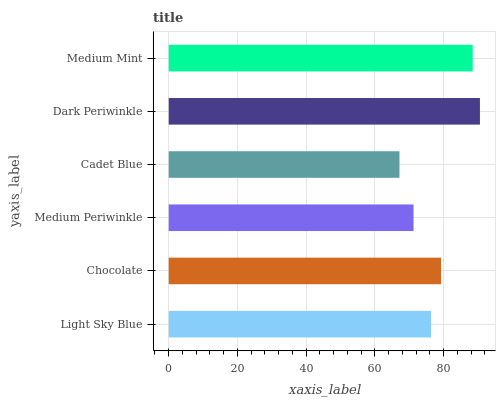Is Cadet Blue the minimum?
Answer yes or no. Yes. Is Dark Periwinkle the maximum?
Answer yes or no. Yes. Is Chocolate the minimum?
Answer yes or no. No. Is Chocolate the maximum?
Answer yes or no. No. Is Chocolate greater than Light Sky Blue?
Answer yes or no. Yes. Is Light Sky Blue less than Chocolate?
Answer yes or no. Yes. Is Light Sky Blue greater than Chocolate?
Answer yes or no. No. Is Chocolate less than Light Sky Blue?
Answer yes or no. No. Is Chocolate the high median?
Answer yes or no. Yes. Is Light Sky Blue the low median?
Answer yes or no. Yes. Is Dark Periwinkle the high median?
Answer yes or no. No. Is Chocolate the low median?
Answer yes or no. No. 